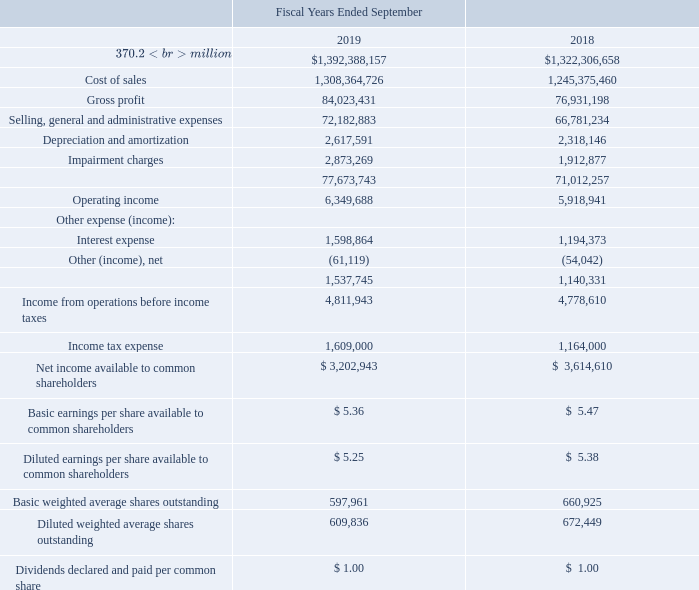CONSOLIDATED STATEMENTS OF OPERATIONS
The accompanying notes are an integral part of these consolidated financial statements.
What are the respective sales in the fiscal years ended September 2018 and 2019? $1,322,306,658, $1,392,388,157. What are the respective cost of sales in the fiscal years ended September 2018 and 2019? 1,245,375,460, 1,308,364,726. What are the respective gross profit in the fiscal years ended September 2018 and 2019? 76,931,198, 84,023,431. What is the percentage change in the company's sales between the fiscal years ended September 2018 and 2019?
Answer scale should be: percent. (1,392,388,157 - 1,322,306,658)/1,322,306,658 
Answer: 5.3. What is the percentage change in the company's cost of sales between the fiscal years ended September 2018 and 2019?
Answer scale should be: percent. (1,308,364,726 - 1,245,375,460)/1,245,375,460 
Answer: 5.06. What is the percentage change in the company's gross profit between the fiscal years ended September 2018 and 2019?
Answer scale should be: percent. (84,023,431 - 76,931,198)/76,931,198 
Answer: 9.22. 